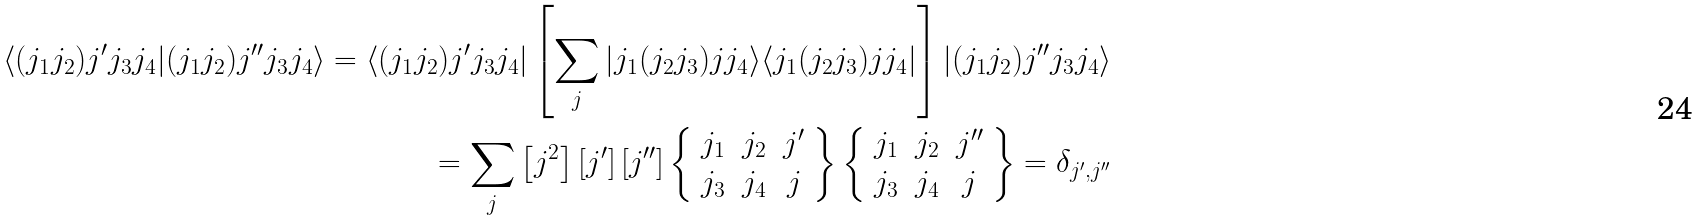<formula> <loc_0><loc_0><loc_500><loc_500>\langle ( j _ { 1 } j _ { 2 } ) j ^ { \prime } j _ { 3 } j _ { 4 } | ( j _ { 1 } j _ { 2 } ) j ^ { \prime \prime } j _ { 3 } j _ { 4 } \rangle = \langle ( j _ { 1 } j _ { 2 } ) j ^ { \prime } j _ { 3 } j _ { 4 } | \left [ \sum _ { j } | j _ { 1 } ( j _ { 2 } j _ { 3 } ) j j _ { 4 } \rangle \langle j _ { 1 } ( j _ { 2 } j _ { 3 } ) j j _ { 4 } | \right ] | ( j _ { 1 } j _ { 2 } ) j ^ { \prime \prime } j _ { 3 } j _ { 4 } \rangle \\ = \sum _ { j } \left [ j ^ { 2 } \right ] \left [ j ^ { \prime } \right ] \left [ j ^ { \prime \prime } \right ] \left \{ \begin{array} { c c c } j _ { 1 } & j _ { 2 } & j ^ { \prime } \\ j _ { 3 } & j _ { 4 } & j \end{array} \right \} \left \{ \begin{array} { c c c } j _ { 1 } & j _ { 2 } & j ^ { \prime \prime } \\ j _ { 3 } & j _ { 4 } & j \end{array} \right \} = \delta _ { j ^ { \prime } , j ^ { \prime \prime } }</formula> 